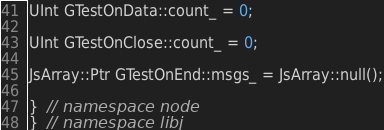<code> <loc_0><loc_0><loc_500><loc_500><_C++_>
UInt GTestOnData::count_ = 0;

UInt GTestOnClose::count_ = 0;

JsArray::Ptr GTestOnEnd::msgs_ = JsArray::null();

}  // namespace node
}  // namespace libj
</code> 